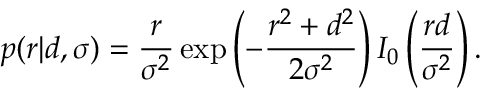Convert formula to latex. <formula><loc_0><loc_0><loc_500><loc_500>p ( r | d , \sigma ) = \frac { r } { \sigma ^ { 2 } } \exp \left ( - \frac { r ^ { 2 } + d ^ { 2 } } { 2 \sigma ^ { 2 } } \right ) I _ { 0 } \left ( \frac { r d } { \sigma ^ { 2 } } \right ) .</formula> 